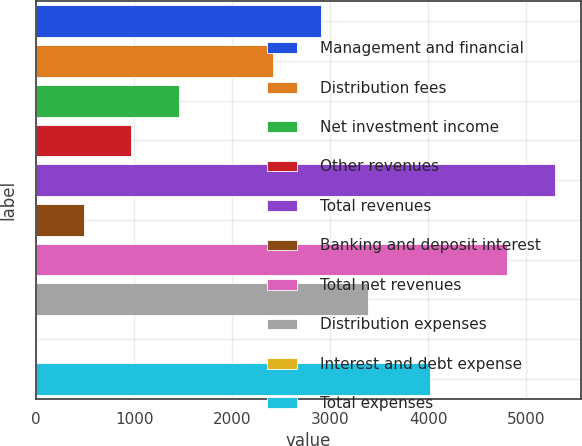Convert chart. <chart><loc_0><loc_0><loc_500><loc_500><bar_chart><fcel>Management and financial<fcel>Distribution fees<fcel>Net investment income<fcel>Other revenues<fcel>Total revenues<fcel>Banking and deposit interest<fcel>Total net revenues<fcel>Distribution expenses<fcel>Interest and debt expense<fcel>Total expenses<nl><fcel>2902.8<fcel>2420<fcel>1454.4<fcel>971.6<fcel>5288.8<fcel>488.8<fcel>4806<fcel>3385.6<fcel>6<fcel>4014<nl></chart> 